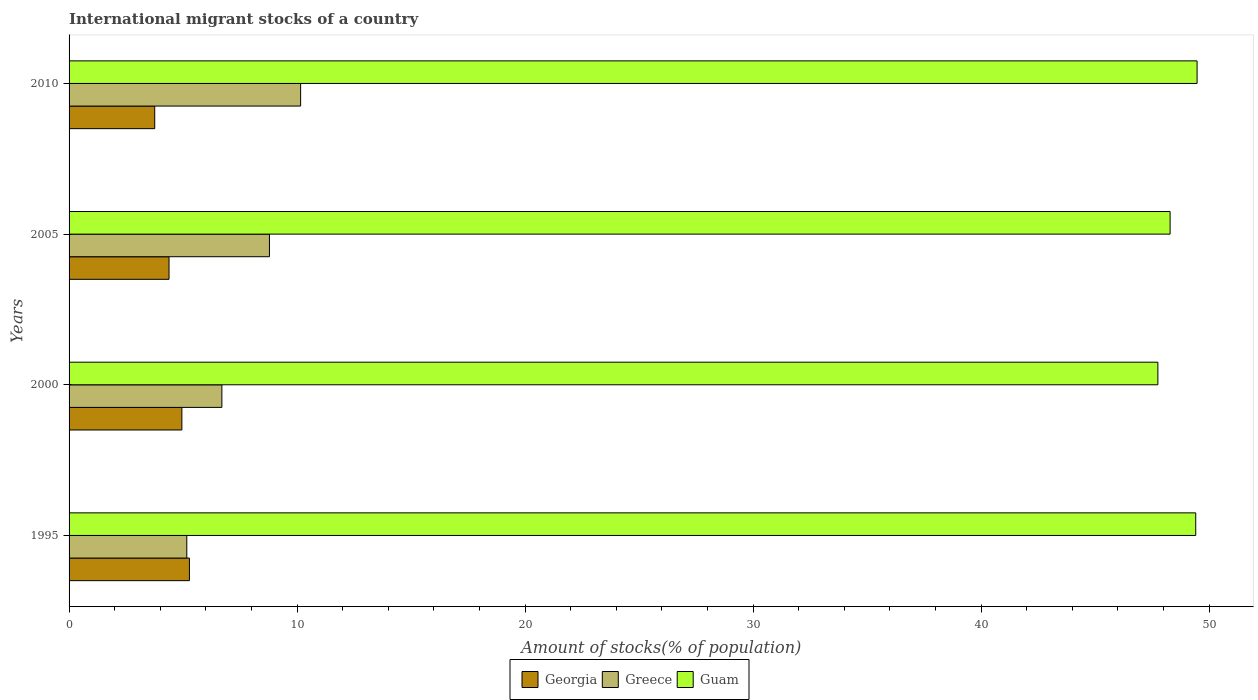In how many cases, is the number of bars for a given year not equal to the number of legend labels?
Make the answer very short. 0. What is the amount of stocks in in Greece in 1995?
Keep it short and to the point. 5.16. Across all years, what is the maximum amount of stocks in in Guam?
Provide a succinct answer. 49.48. Across all years, what is the minimum amount of stocks in in Guam?
Make the answer very short. 47.76. In which year was the amount of stocks in in Georgia maximum?
Your answer should be compact. 1995. What is the total amount of stocks in in Greece in the graph?
Provide a short and direct response. 30.81. What is the difference between the amount of stocks in in Greece in 1995 and that in 2005?
Your answer should be very brief. -3.63. What is the difference between the amount of stocks in in Guam in 2005 and the amount of stocks in in Greece in 2000?
Offer a very short reply. 41.59. What is the average amount of stocks in in Greece per year?
Provide a succinct answer. 7.7. In the year 2010, what is the difference between the amount of stocks in in Guam and amount of stocks in in Georgia?
Make the answer very short. 45.72. What is the ratio of the amount of stocks in in Georgia in 2005 to that in 2010?
Your answer should be compact. 1.17. What is the difference between the highest and the second highest amount of stocks in in Guam?
Offer a very short reply. 0.06. What is the difference between the highest and the lowest amount of stocks in in Georgia?
Ensure brevity in your answer.  1.52. In how many years, is the amount of stocks in in Guam greater than the average amount of stocks in in Guam taken over all years?
Make the answer very short. 2. Is the sum of the amount of stocks in in Greece in 1995 and 2010 greater than the maximum amount of stocks in in Guam across all years?
Provide a short and direct response. No. What does the 1st bar from the top in 2005 represents?
Provide a short and direct response. Guam. What does the 2nd bar from the bottom in 2010 represents?
Give a very brief answer. Greece. Are all the bars in the graph horizontal?
Offer a very short reply. Yes. Are the values on the major ticks of X-axis written in scientific E-notation?
Give a very brief answer. No. Does the graph contain any zero values?
Give a very brief answer. No. Does the graph contain grids?
Provide a short and direct response. No. Where does the legend appear in the graph?
Give a very brief answer. Bottom center. How many legend labels are there?
Give a very brief answer. 3. What is the title of the graph?
Keep it short and to the point. International migrant stocks of a country. Does "Marshall Islands" appear as one of the legend labels in the graph?
Ensure brevity in your answer.  No. What is the label or title of the X-axis?
Your answer should be compact. Amount of stocks(% of population). What is the Amount of stocks(% of population) in Georgia in 1995?
Offer a terse response. 5.28. What is the Amount of stocks(% of population) in Greece in 1995?
Give a very brief answer. 5.16. What is the Amount of stocks(% of population) in Guam in 1995?
Provide a succinct answer. 49.42. What is the Amount of stocks(% of population) in Georgia in 2000?
Offer a terse response. 4.95. What is the Amount of stocks(% of population) of Greece in 2000?
Your answer should be compact. 6.7. What is the Amount of stocks(% of population) of Guam in 2000?
Provide a short and direct response. 47.76. What is the Amount of stocks(% of population) of Georgia in 2005?
Offer a terse response. 4.38. What is the Amount of stocks(% of population) of Greece in 2005?
Make the answer very short. 8.79. What is the Amount of stocks(% of population) in Guam in 2005?
Keep it short and to the point. 48.29. What is the Amount of stocks(% of population) of Georgia in 2010?
Offer a very short reply. 3.76. What is the Amount of stocks(% of population) of Greece in 2010?
Your answer should be compact. 10.16. What is the Amount of stocks(% of population) in Guam in 2010?
Your answer should be very brief. 49.48. Across all years, what is the maximum Amount of stocks(% of population) of Georgia?
Your answer should be very brief. 5.28. Across all years, what is the maximum Amount of stocks(% of population) in Greece?
Make the answer very short. 10.16. Across all years, what is the maximum Amount of stocks(% of population) of Guam?
Provide a short and direct response. 49.48. Across all years, what is the minimum Amount of stocks(% of population) of Georgia?
Make the answer very short. 3.76. Across all years, what is the minimum Amount of stocks(% of population) of Greece?
Ensure brevity in your answer.  5.16. Across all years, what is the minimum Amount of stocks(% of population) in Guam?
Offer a very short reply. 47.76. What is the total Amount of stocks(% of population) of Georgia in the graph?
Make the answer very short. 18.37. What is the total Amount of stocks(% of population) in Greece in the graph?
Make the answer very short. 30.81. What is the total Amount of stocks(% of population) in Guam in the graph?
Give a very brief answer. 194.95. What is the difference between the Amount of stocks(% of population) of Georgia in 1995 and that in 2000?
Keep it short and to the point. 0.33. What is the difference between the Amount of stocks(% of population) in Greece in 1995 and that in 2000?
Your response must be concise. -1.54. What is the difference between the Amount of stocks(% of population) of Guam in 1995 and that in 2000?
Make the answer very short. 1.66. What is the difference between the Amount of stocks(% of population) in Georgia in 1995 and that in 2005?
Your answer should be compact. 0.89. What is the difference between the Amount of stocks(% of population) in Greece in 1995 and that in 2005?
Your answer should be very brief. -3.63. What is the difference between the Amount of stocks(% of population) in Guam in 1995 and that in 2005?
Provide a succinct answer. 1.12. What is the difference between the Amount of stocks(% of population) in Georgia in 1995 and that in 2010?
Your response must be concise. 1.52. What is the difference between the Amount of stocks(% of population) in Greece in 1995 and that in 2010?
Give a very brief answer. -4.99. What is the difference between the Amount of stocks(% of population) in Guam in 1995 and that in 2010?
Give a very brief answer. -0.06. What is the difference between the Amount of stocks(% of population) of Georgia in 2000 and that in 2005?
Your answer should be compact. 0.56. What is the difference between the Amount of stocks(% of population) of Greece in 2000 and that in 2005?
Offer a very short reply. -2.09. What is the difference between the Amount of stocks(% of population) in Guam in 2000 and that in 2005?
Your answer should be very brief. -0.54. What is the difference between the Amount of stocks(% of population) in Georgia in 2000 and that in 2010?
Your response must be concise. 1.19. What is the difference between the Amount of stocks(% of population) in Greece in 2000 and that in 2010?
Offer a very short reply. -3.45. What is the difference between the Amount of stocks(% of population) of Guam in 2000 and that in 2010?
Offer a terse response. -1.72. What is the difference between the Amount of stocks(% of population) in Georgia in 2005 and that in 2010?
Your answer should be very brief. 0.63. What is the difference between the Amount of stocks(% of population) of Greece in 2005 and that in 2010?
Give a very brief answer. -1.37. What is the difference between the Amount of stocks(% of population) in Guam in 2005 and that in 2010?
Offer a terse response. -1.18. What is the difference between the Amount of stocks(% of population) of Georgia in 1995 and the Amount of stocks(% of population) of Greece in 2000?
Your answer should be compact. -1.42. What is the difference between the Amount of stocks(% of population) in Georgia in 1995 and the Amount of stocks(% of population) in Guam in 2000?
Keep it short and to the point. -42.48. What is the difference between the Amount of stocks(% of population) of Greece in 1995 and the Amount of stocks(% of population) of Guam in 2000?
Provide a succinct answer. -42.59. What is the difference between the Amount of stocks(% of population) in Georgia in 1995 and the Amount of stocks(% of population) in Greece in 2005?
Offer a very short reply. -3.51. What is the difference between the Amount of stocks(% of population) of Georgia in 1995 and the Amount of stocks(% of population) of Guam in 2005?
Give a very brief answer. -43.02. What is the difference between the Amount of stocks(% of population) in Greece in 1995 and the Amount of stocks(% of population) in Guam in 2005?
Your answer should be compact. -43.13. What is the difference between the Amount of stocks(% of population) of Georgia in 1995 and the Amount of stocks(% of population) of Greece in 2010?
Offer a very short reply. -4.88. What is the difference between the Amount of stocks(% of population) of Georgia in 1995 and the Amount of stocks(% of population) of Guam in 2010?
Your response must be concise. -44.2. What is the difference between the Amount of stocks(% of population) of Greece in 1995 and the Amount of stocks(% of population) of Guam in 2010?
Make the answer very short. -44.31. What is the difference between the Amount of stocks(% of population) of Georgia in 2000 and the Amount of stocks(% of population) of Greece in 2005?
Your response must be concise. -3.84. What is the difference between the Amount of stocks(% of population) of Georgia in 2000 and the Amount of stocks(% of population) of Guam in 2005?
Ensure brevity in your answer.  -43.35. What is the difference between the Amount of stocks(% of population) in Greece in 2000 and the Amount of stocks(% of population) in Guam in 2005?
Give a very brief answer. -41.59. What is the difference between the Amount of stocks(% of population) in Georgia in 2000 and the Amount of stocks(% of population) in Greece in 2010?
Your response must be concise. -5.21. What is the difference between the Amount of stocks(% of population) in Georgia in 2000 and the Amount of stocks(% of population) in Guam in 2010?
Give a very brief answer. -44.53. What is the difference between the Amount of stocks(% of population) of Greece in 2000 and the Amount of stocks(% of population) of Guam in 2010?
Make the answer very short. -42.78. What is the difference between the Amount of stocks(% of population) of Georgia in 2005 and the Amount of stocks(% of population) of Greece in 2010?
Ensure brevity in your answer.  -5.77. What is the difference between the Amount of stocks(% of population) of Georgia in 2005 and the Amount of stocks(% of population) of Guam in 2010?
Your response must be concise. -45.09. What is the difference between the Amount of stocks(% of population) of Greece in 2005 and the Amount of stocks(% of population) of Guam in 2010?
Offer a very short reply. -40.69. What is the average Amount of stocks(% of population) in Georgia per year?
Your response must be concise. 4.59. What is the average Amount of stocks(% of population) of Greece per year?
Provide a short and direct response. 7.7. What is the average Amount of stocks(% of population) in Guam per year?
Your response must be concise. 48.74. In the year 1995, what is the difference between the Amount of stocks(% of population) of Georgia and Amount of stocks(% of population) of Greece?
Keep it short and to the point. 0.12. In the year 1995, what is the difference between the Amount of stocks(% of population) in Georgia and Amount of stocks(% of population) in Guam?
Make the answer very short. -44.14. In the year 1995, what is the difference between the Amount of stocks(% of population) of Greece and Amount of stocks(% of population) of Guam?
Offer a terse response. -44.25. In the year 2000, what is the difference between the Amount of stocks(% of population) of Georgia and Amount of stocks(% of population) of Greece?
Offer a terse response. -1.75. In the year 2000, what is the difference between the Amount of stocks(% of population) of Georgia and Amount of stocks(% of population) of Guam?
Ensure brevity in your answer.  -42.81. In the year 2000, what is the difference between the Amount of stocks(% of population) in Greece and Amount of stocks(% of population) in Guam?
Your response must be concise. -41.06. In the year 2005, what is the difference between the Amount of stocks(% of population) of Georgia and Amount of stocks(% of population) of Greece?
Offer a terse response. -4.41. In the year 2005, what is the difference between the Amount of stocks(% of population) of Georgia and Amount of stocks(% of population) of Guam?
Provide a short and direct response. -43.91. In the year 2005, what is the difference between the Amount of stocks(% of population) of Greece and Amount of stocks(% of population) of Guam?
Your answer should be very brief. -39.5. In the year 2010, what is the difference between the Amount of stocks(% of population) in Georgia and Amount of stocks(% of population) in Greece?
Keep it short and to the point. -6.4. In the year 2010, what is the difference between the Amount of stocks(% of population) in Georgia and Amount of stocks(% of population) in Guam?
Your response must be concise. -45.72. In the year 2010, what is the difference between the Amount of stocks(% of population) in Greece and Amount of stocks(% of population) in Guam?
Offer a terse response. -39.32. What is the ratio of the Amount of stocks(% of population) in Georgia in 1995 to that in 2000?
Your answer should be very brief. 1.07. What is the ratio of the Amount of stocks(% of population) of Greece in 1995 to that in 2000?
Offer a very short reply. 0.77. What is the ratio of the Amount of stocks(% of population) in Guam in 1995 to that in 2000?
Ensure brevity in your answer.  1.03. What is the ratio of the Amount of stocks(% of population) in Georgia in 1995 to that in 2005?
Offer a very short reply. 1.2. What is the ratio of the Amount of stocks(% of population) in Greece in 1995 to that in 2005?
Provide a succinct answer. 0.59. What is the ratio of the Amount of stocks(% of population) of Guam in 1995 to that in 2005?
Offer a terse response. 1.02. What is the ratio of the Amount of stocks(% of population) in Georgia in 1995 to that in 2010?
Keep it short and to the point. 1.41. What is the ratio of the Amount of stocks(% of population) in Greece in 1995 to that in 2010?
Your response must be concise. 0.51. What is the ratio of the Amount of stocks(% of population) of Guam in 1995 to that in 2010?
Provide a succinct answer. 1. What is the ratio of the Amount of stocks(% of population) of Georgia in 2000 to that in 2005?
Give a very brief answer. 1.13. What is the ratio of the Amount of stocks(% of population) in Greece in 2000 to that in 2005?
Your answer should be compact. 0.76. What is the ratio of the Amount of stocks(% of population) in Guam in 2000 to that in 2005?
Give a very brief answer. 0.99. What is the ratio of the Amount of stocks(% of population) of Georgia in 2000 to that in 2010?
Keep it short and to the point. 1.32. What is the ratio of the Amount of stocks(% of population) of Greece in 2000 to that in 2010?
Your answer should be very brief. 0.66. What is the ratio of the Amount of stocks(% of population) of Guam in 2000 to that in 2010?
Provide a short and direct response. 0.97. What is the ratio of the Amount of stocks(% of population) in Georgia in 2005 to that in 2010?
Offer a very short reply. 1.17. What is the ratio of the Amount of stocks(% of population) of Greece in 2005 to that in 2010?
Ensure brevity in your answer.  0.87. What is the ratio of the Amount of stocks(% of population) of Guam in 2005 to that in 2010?
Provide a succinct answer. 0.98. What is the difference between the highest and the second highest Amount of stocks(% of population) in Georgia?
Your response must be concise. 0.33. What is the difference between the highest and the second highest Amount of stocks(% of population) in Greece?
Provide a short and direct response. 1.37. What is the difference between the highest and the second highest Amount of stocks(% of population) of Guam?
Offer a very short reply. 0.06. What is the difference between the highest and the lowest Amount of stocks(% of population) of Georgia?
Provide a succinct answer. 1.52. What is the difference between the highest and the lowest Amount of stocks(% of population) in Greece?
Keep it short and to the point. 4.99. What is the difference between the highest and the lowest Amount of stocks(% of population) in Guam?
Your response must be concise. 1.72. 